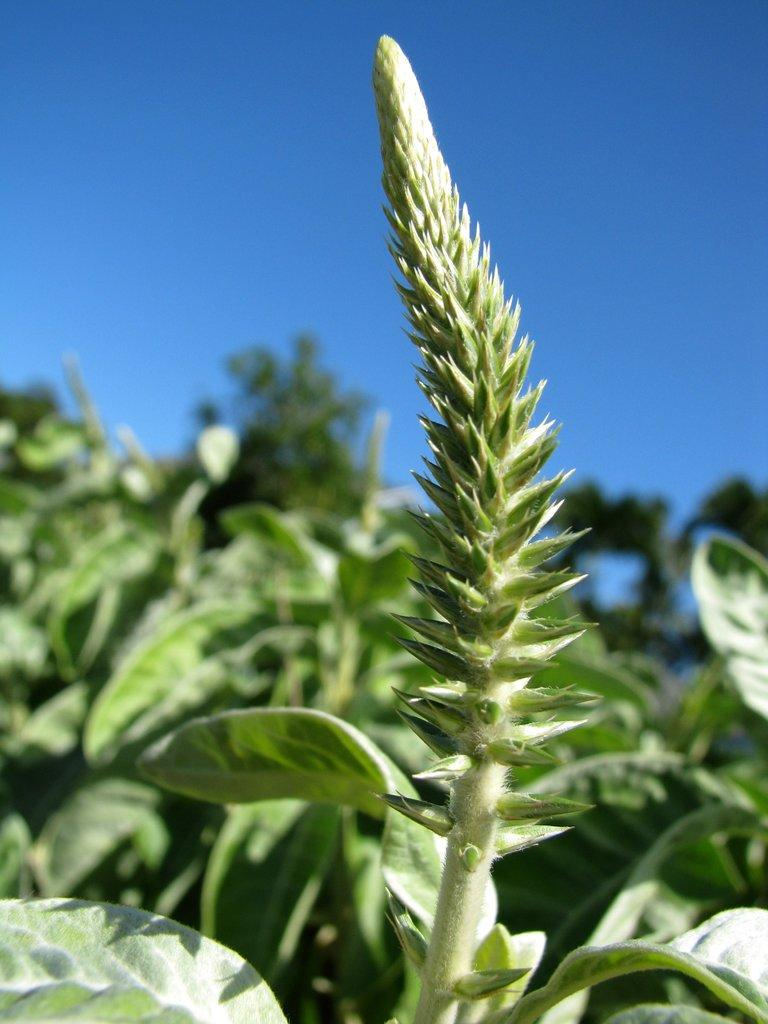What type of living organisms can be seen in the image? There are plants on the ground in the image. What is the color of the plants in the image? The plants are green in color. What can be seen in the background of the image? There is a sky visible in the background of the image. Can you see a nest made of cards in the image? There is no nest or cards present in the image; it features plants on the ground and a sky in the background. 